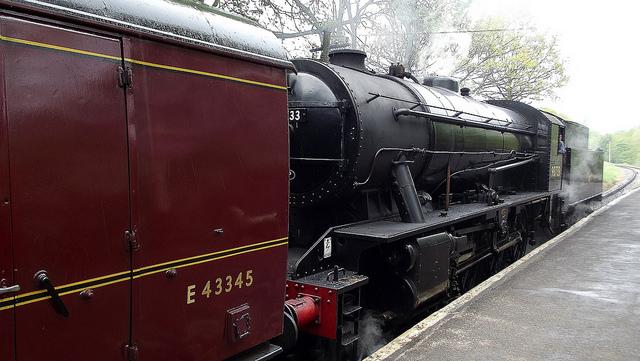Is this train damaged?
Be succinct. No. Is this train indoors or outdoors?
Quick response, please. Outdoors. Which would cause the most damage in an accident: your car or this vehicle?
Give a very brief answer. This vehicle. Is this a passenger train?
Keep it brief. Yes. Is this a steam powered train engine?
Short answer required. Yes. 